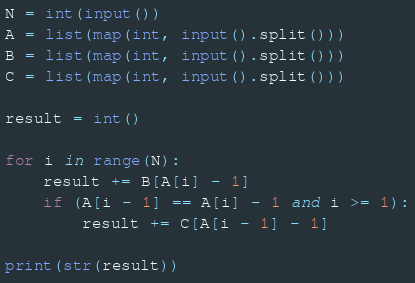<code> <loc_0><loc_0><loc_500><loc_500><_Python_>N = int(input())
A = list(map(int, input().split()))
B = list(map(int, input().split()))
C = list(map(int, input().split()))

result = int()

for i in range(N):
    result += B[A[i] - 1]
    if (A[i - 1] == A[i] - 1 and i >= 1):
        result += C[A[i - 1] - 1]

print(str(result))</code> 